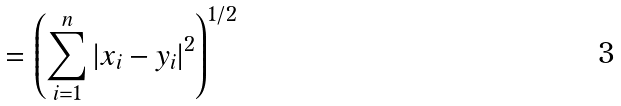Convert formula to latex. <formula><loc_0><loc_0><loc_500><loc_500>= \left ( \sum _ { i = 1 } ^ { n } \left | x _ { i } - y _ { i } \right | ^ { 2 } \right ) ^ { 1 / 2 }</formula> 